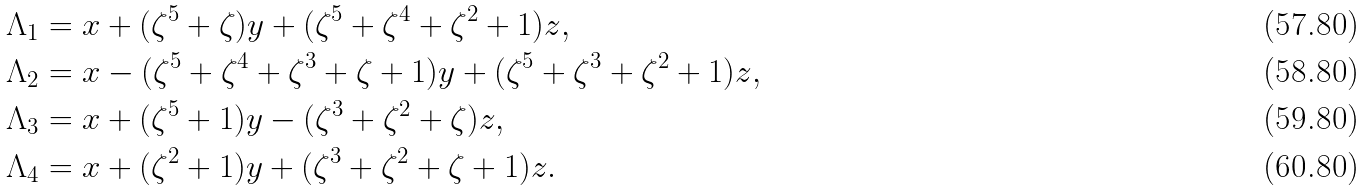<formula> <loc_0><loc_0><loc_500><loc_500>\Lambda _ { 1 } & = x + ( \zeta ^ { 5 } + \zeta ) y + ( \zeta ^ { 5 } + \zeta ^ { 4 } + \zeta ^ { 2 } + 1 ) z , \\ \Lambda _ { 2 } & = x - ( \zeta ^ { 5 } + \zeta ^ { 4 } + \zeta ^ { 3 } + \zeta + 1 ) y + ( \zeta ^ { 5 } + \zeta ^ { 3 } + \zeta ^ { 2 } + 1 ) z , \\ \Lambda _ { 3 } & = x + ( \zeta ^ { 5 } + 1 ) y - ( \zeta ^ { 3 } + \zeta ^ { 2 } + \zeta ) z , \\ \Lambda _ { 4 } & = x + ( \zeta ^ { 2 } + 1 ) y + ( \zeta ^ { 3 } + \zeta ^ { 2 } + \zeta + 1 ) z .</formula> 